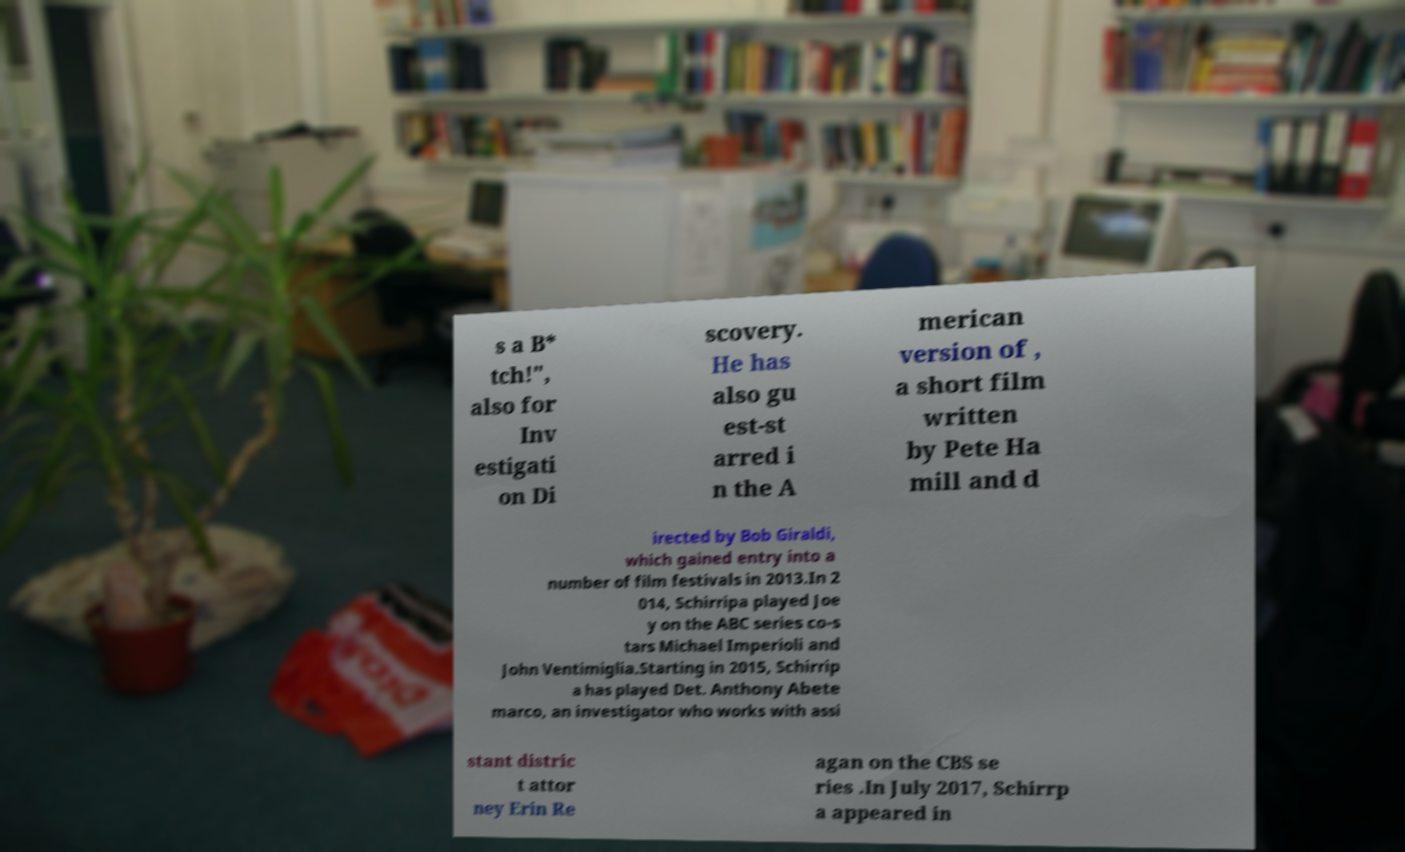Can you accurately transcribe the text from the provided image for me? s a B* tch!", also for Inv estigati on Di scovery. He has also gu est-st arred i n the A merican version of , a short film written by Pete Ha mill and d irected by Bob Giraldi, which gained entry into a number of film festivals in 2013.In 2 014, Schirripa played Joe y on the ABC series co-s tars Michael Imperioli and John Ventimiglia.Starting in 2015, Schirrip a has played Det. Anthony Abete marco, an investigator who works with assi stant distric t attor ney Erin Re agan on the CBS se ries .In July 2017, Schirrp a appeared in 